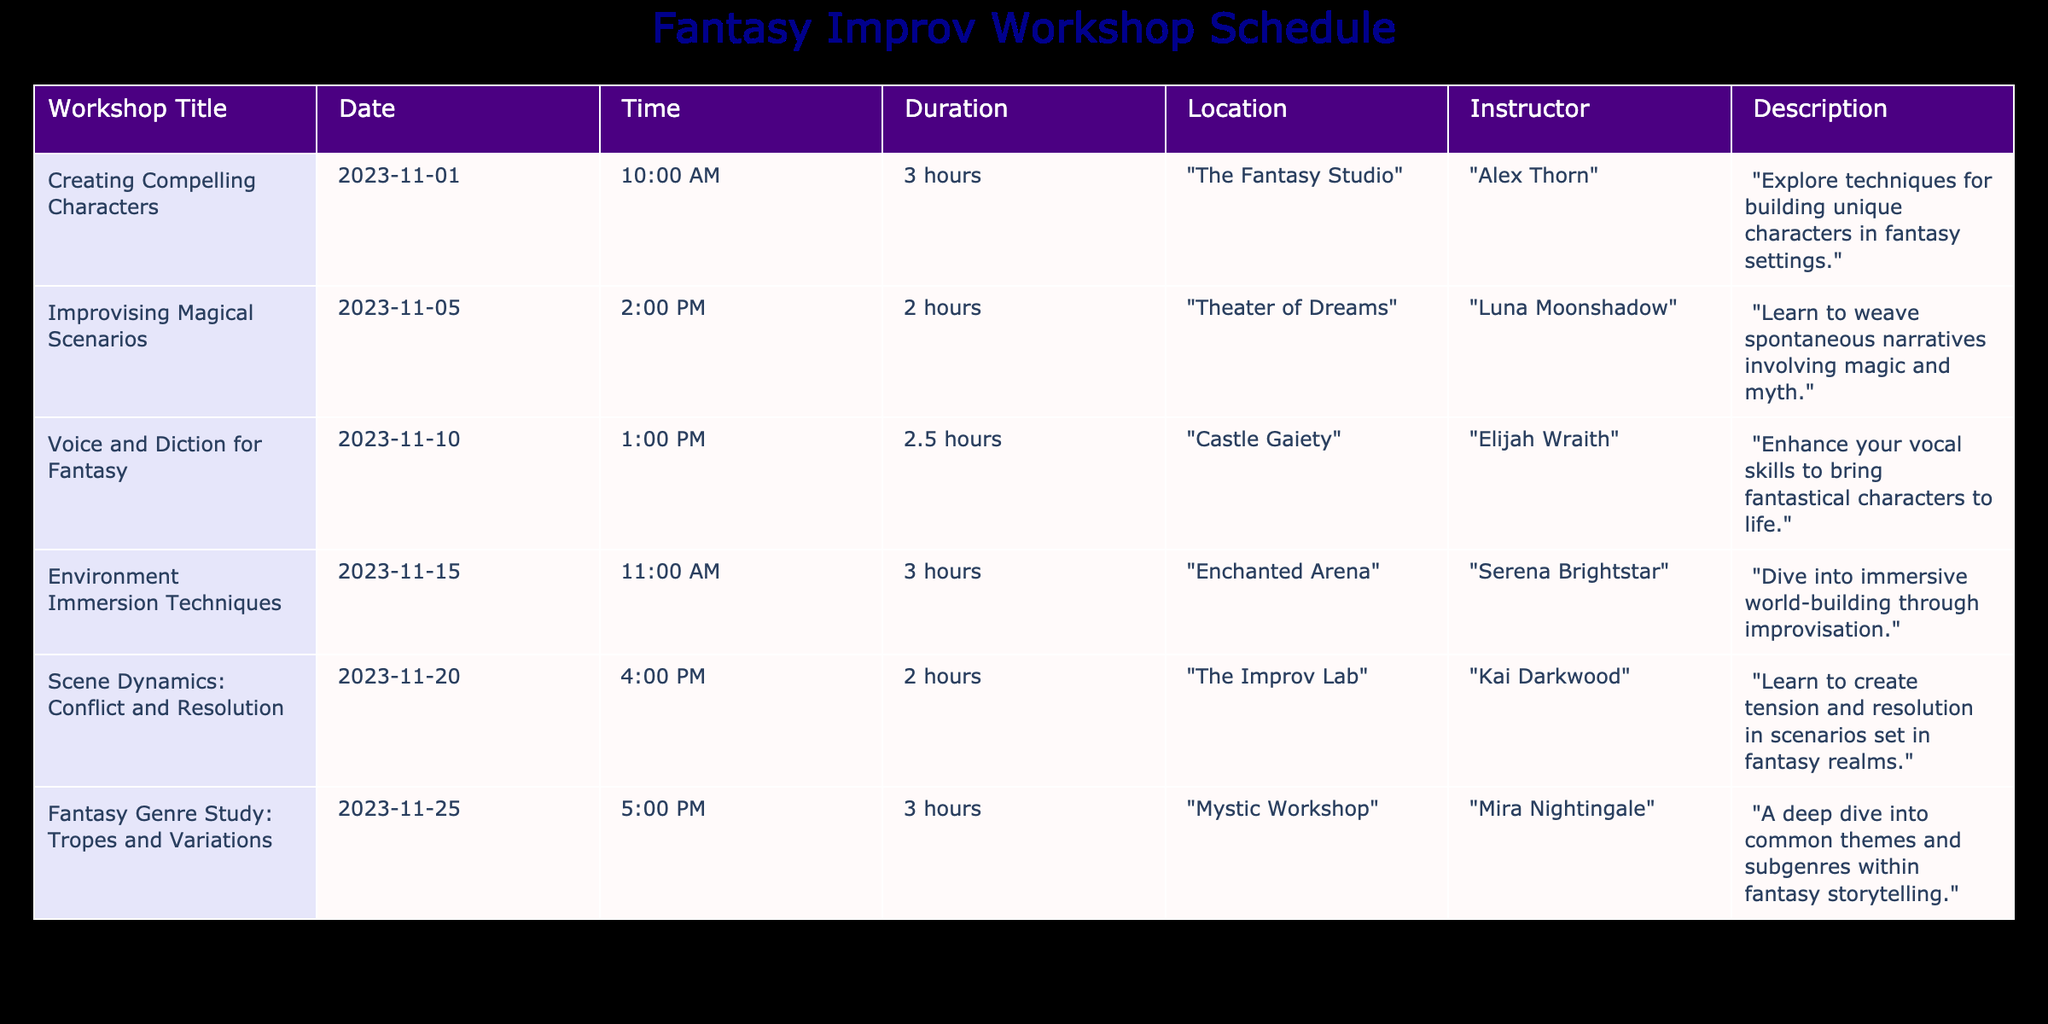what is the title of the workshop on November 15, 2023? From the table, we can directly locate the row with the date "2023-11-15" and read the corresponding workshop title, which is "Environment Immersion Techniques."
Answer: Environment Immersion Techniques who is the instructor for the workshop "Voice and Diction for Fantasy"? The table shows the row for the workshop "Voice and Diction for Fantasy," and the instructor listed there is "Elijah Wraith."
Answer: Elijah Wraith how long is "Improvising Magical Scenarios"? The workshop "Improvising Magical Scenarios" has a duration of 2 hours as indicated in the table.
Answer: 2 hours which workshop takes place at "Theater of Dreams"? By looking at the location column, we find that "Improvising Magical Scenarios" is scheduled at "Theater of Dreams."
Answer: Improvising Magical Scenarios how many hours are scheduled for workshops on November 1 and November 5? The total duration for workshops on those dates is calculated as follows: "Creating Compelling Characters" is 3 hours and "Improvising Magical Scenarios" is 2 hours, so the total is 3 + 2 = 5 hours.
Answer: 5 hours is there a workshop on character creation? The workshop titled "Creating Compelling Characters" focuses specifically on character creation techniques in fantasy settings, confirming that there is indeed a workshop on this topic.
Answer: Yes what is the average duration of all workshops listed? To compute the average, we first sum the durations: 3 + 2 + 2.5 + 3 + 2 + 3 = 16.5 hours. There are 6 workshops, so we divide: 16.5 / 6 = 2.75 hours.
Answer: 2.75 hours which workshop focuses on tension and resolution in fantasy? By examining the descriptions, we see "Scene Dynamics: Conflict and Resolution" specifically addresses creating tension and resolution within fantasy scenarios.
Answer: Scene Dynamics: Conflict and Resolution what day of the week does the "Fantasy Genre Study: Tropes and Variations" workshop occur? The date for this workshop is November 25, 2023, which falls on a Saturday. We can determine the day of the week by referencing a calendar.
Answer: Saturday how many workshops are conducted by female instructors? Reviewing the instructors listed, we find "Luna Moonshadow," "Serena Brightstar," and "Mira Nightingale," which totals 3 female instructors out of the 6 workshops.
Answer: 3 